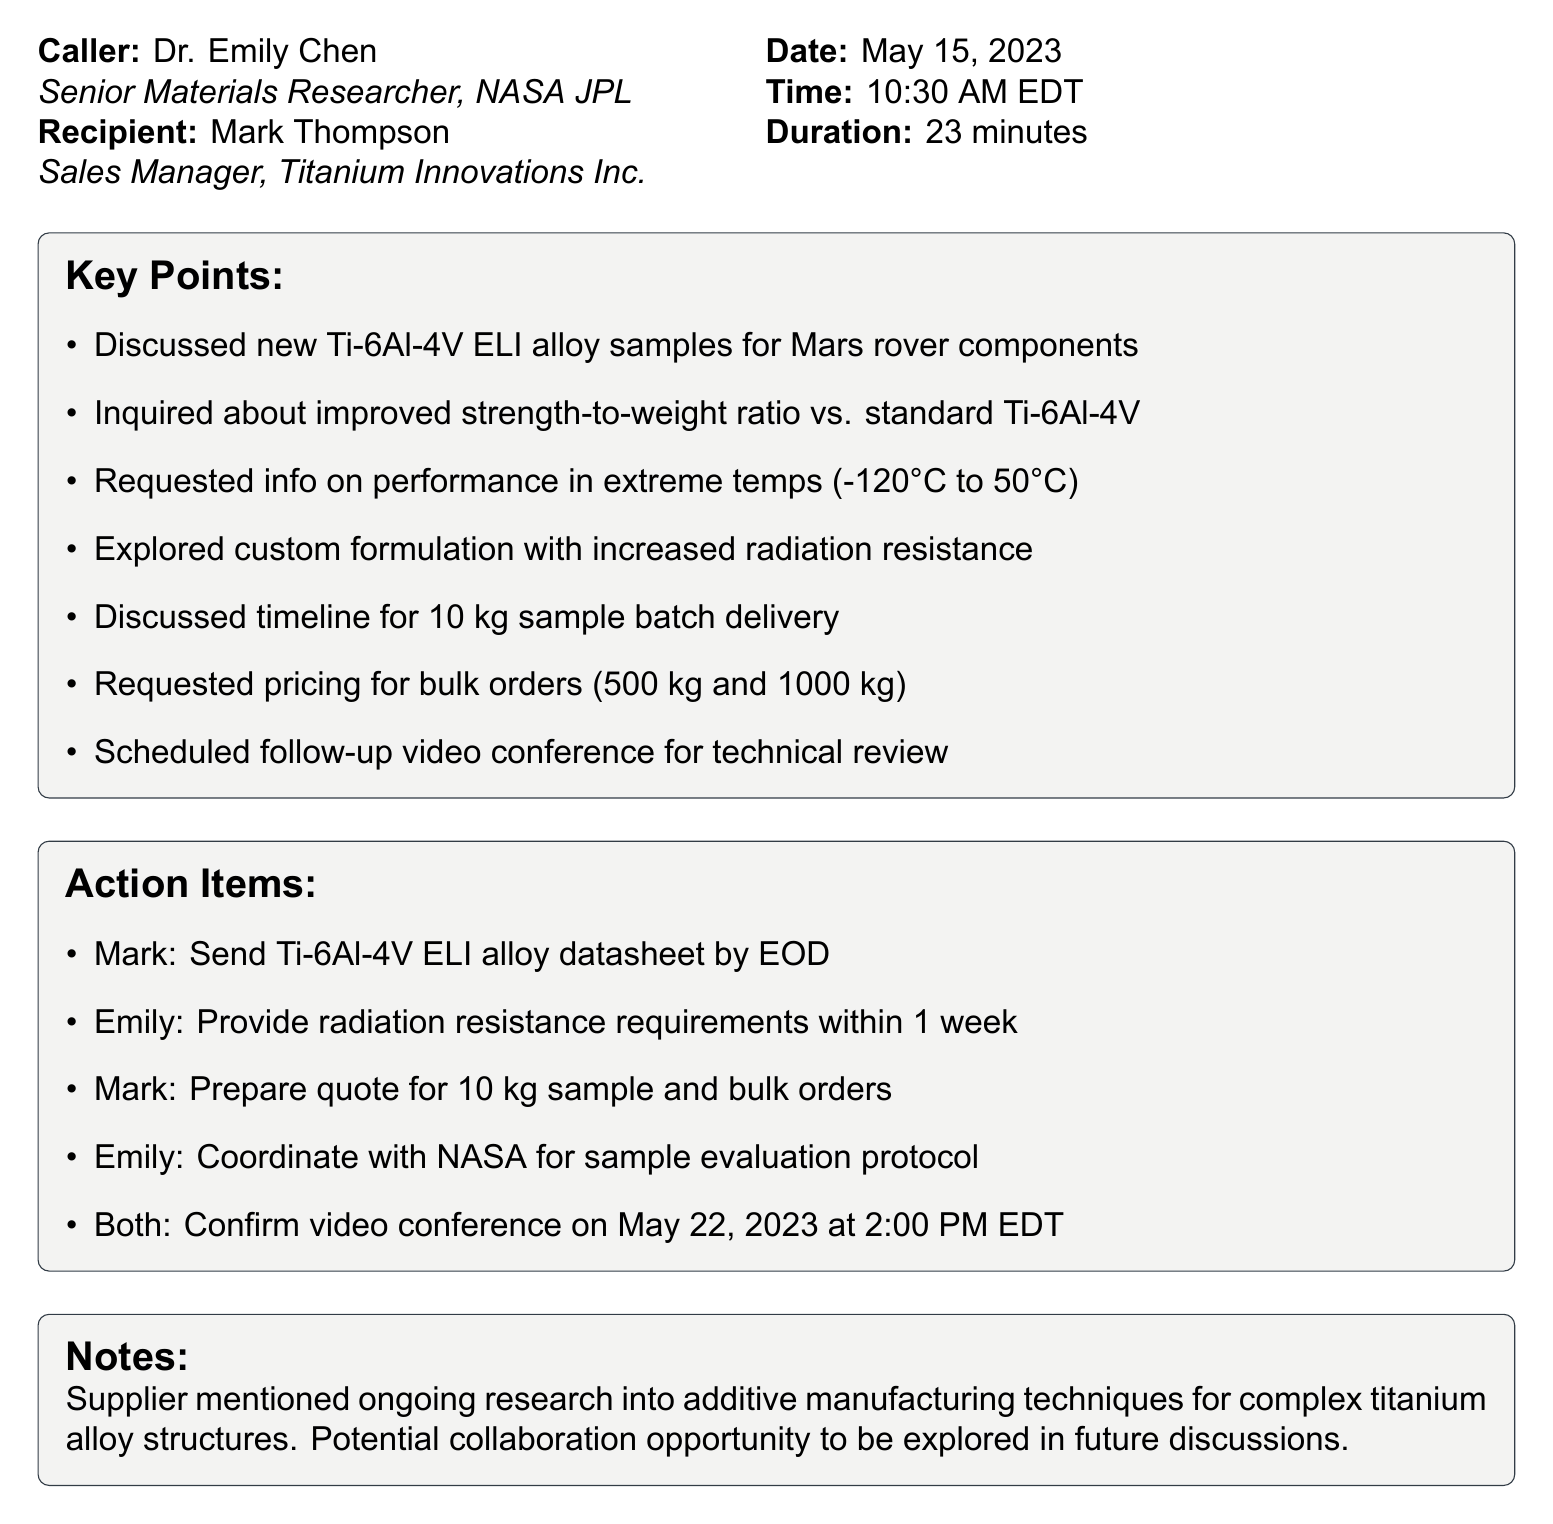What alloy was discussed? The conversation focused on the Ti-6Al-4V ELI alloy samples intended for Mars rover components.
Answer: Ti-6Al-4V ELI Who is the Sales Manager at Titanium Innovations Inc.? The document specifies Mark Thompson as the Sales Manager, who was the recipient of the call.
Answer: Mark Thompson What was the duration of the call? The telephone record indicates that the conversation lasted 23 minutes in total.
Answer: 23 minutes What extreme temperature range was inquired about? The data includes a request for information on performance in temperatures ranging from -120°C to 50°C.
Answer: -120°C to 50°C When is the follow-up video conference scheduled? The telephone record states that the video conference is confirmed for May 22, 2023, at 2:00 PM EDT.
Answer: May 22, 2023 at 2:00 PM EDT What action is Mark supposed to take after the call? Mark is tasked with sending the Ti-6Al-4V ELI alloy datasheet by the end of the day.
Answer: Send datasheet by EOD What opportunity did the supplier mention? The supplier mentioned a potential collaboration opportunity regarding additive manufacturing techniques for titanium alloy structures.
Answer: Potential collaboration opportunity Why is understanding the strength-to-weight ratio crucial? The inquiry into the improved strength-to-weight ratio versus standard Ti-6Al-4V suggests the importance of optimizing material properties for space applications.
Answer: Optimizing material properties for space applications What was discussed regarding custom formulations? The discussion included exploring a custom formulation with increased radiation resistance for better performance in space environments.
Answer: Increased radiation resistance 